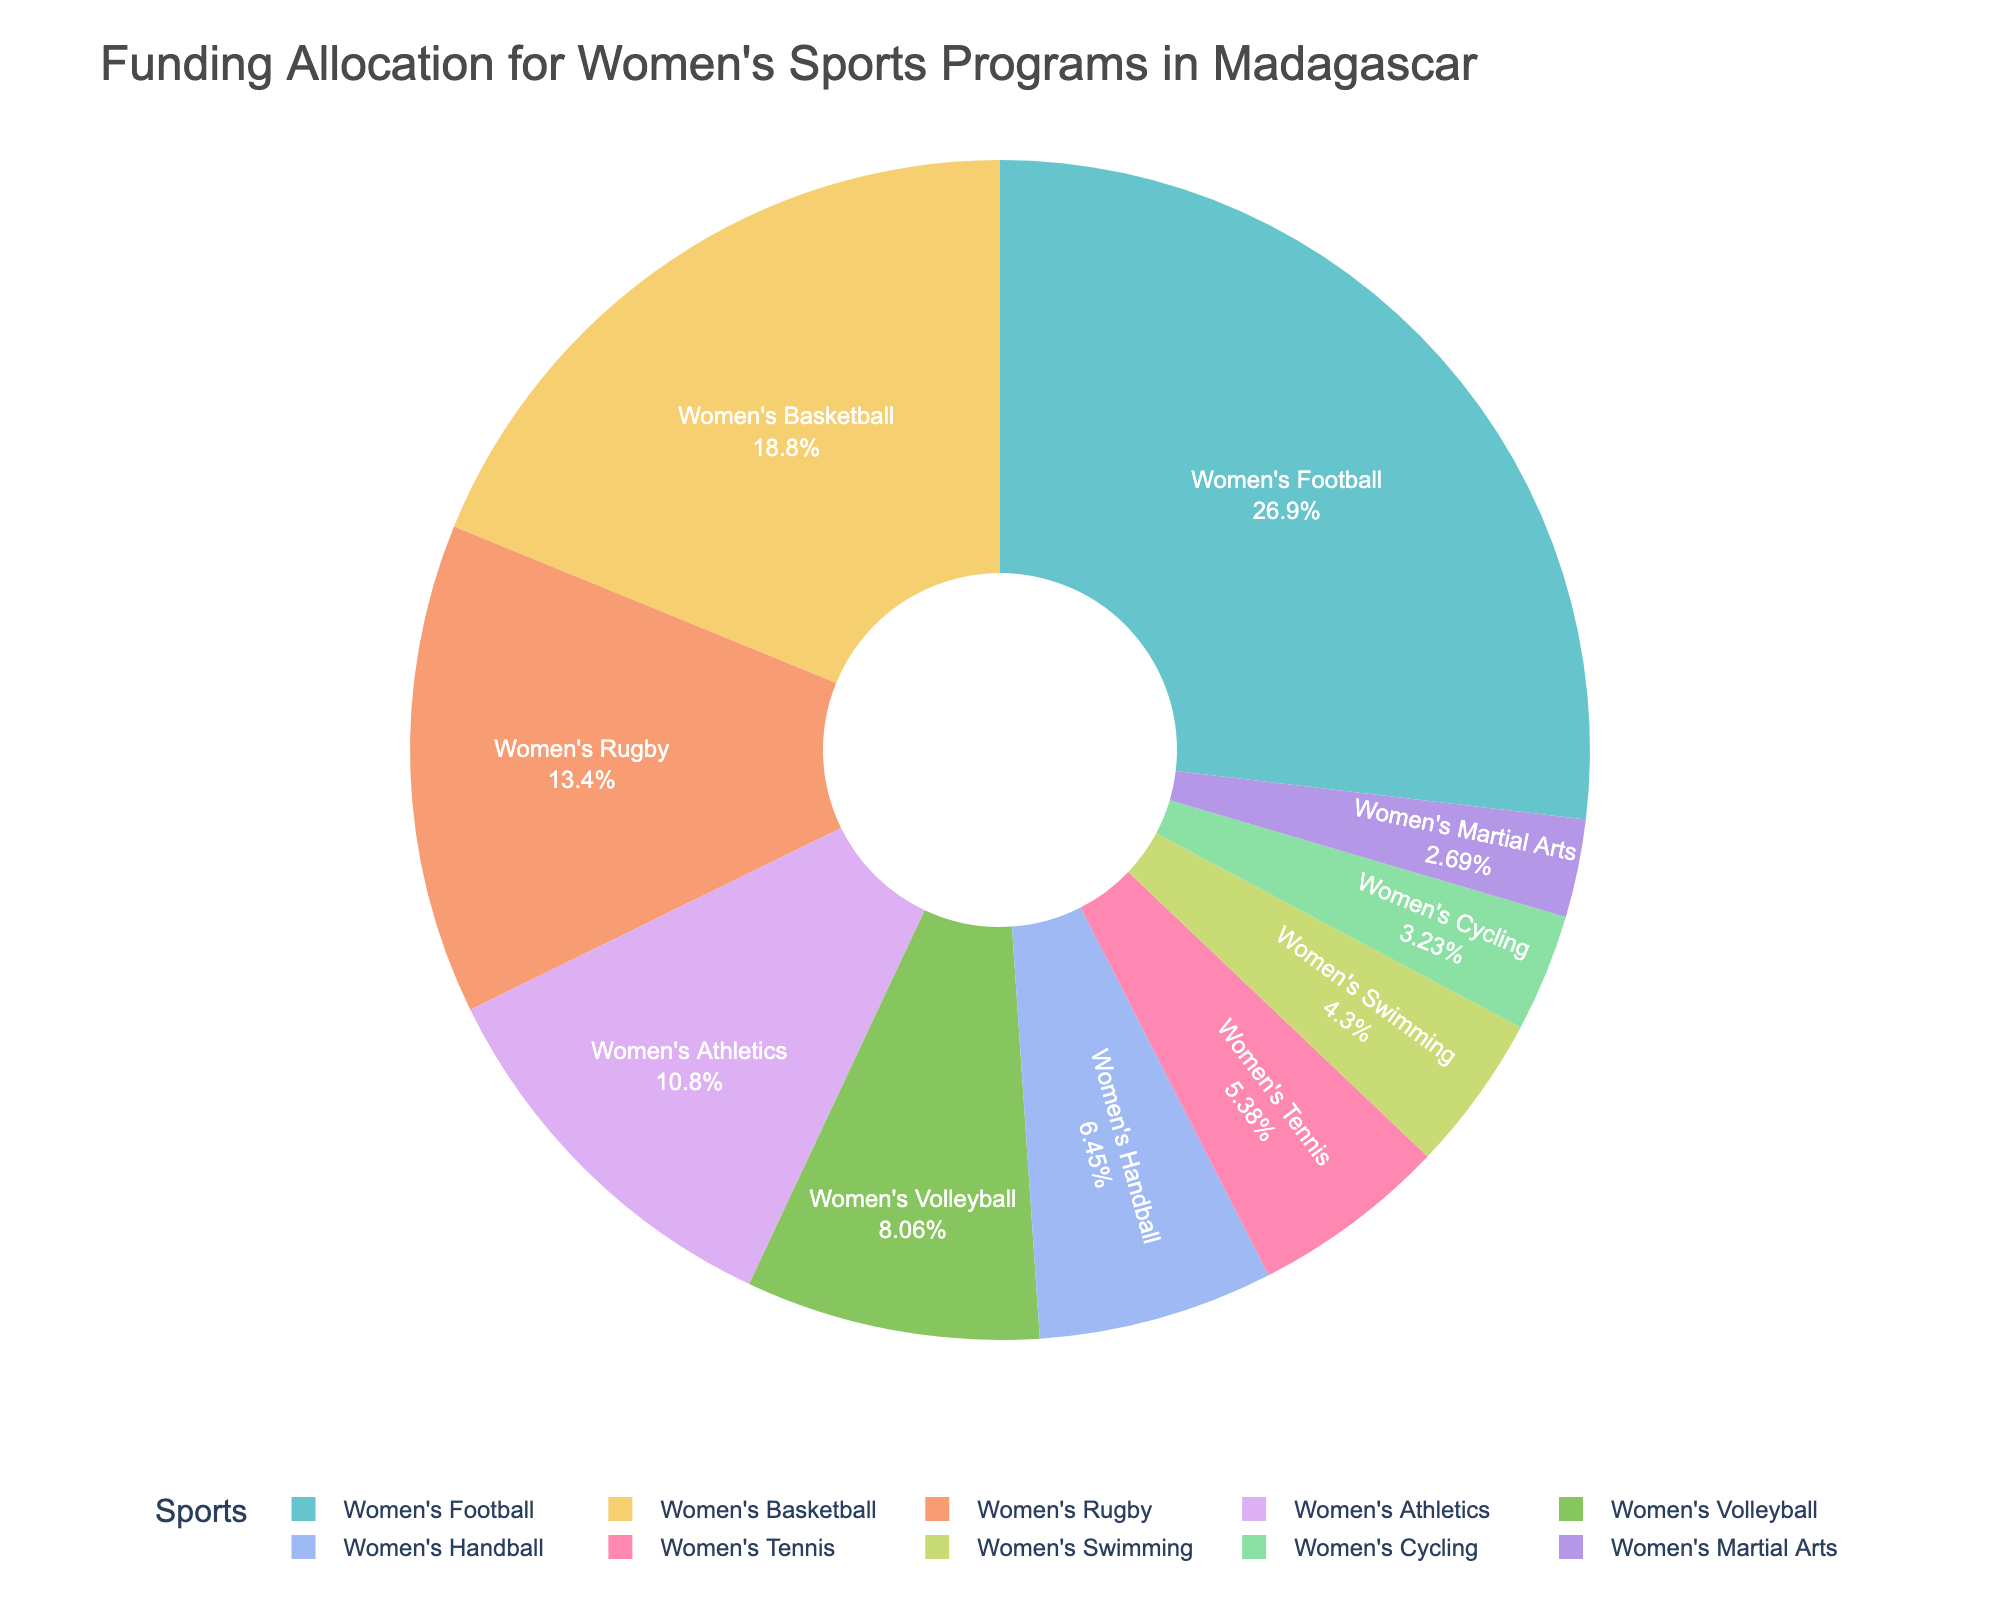What percentage of the total funding is allocated to women's football? To find the percentage of total funding allocated to women's football, divide the funding for women's football (125,000,000 Malagasy Ariary) by the total funding and multiply by 100. From the pie chart, the percentage is displayed directly.
Answer: 30.0% Which sport receives the least funding? Look for the smallest slice in the pie chart. The smallest slice represents the sport with the least funding, which, from the data, is women's martial arts.
Answer: Women's Martial Arts What is the combined funding percentage for women's basketball and women's volleyball? Add the percentages for women's basketball and women's volleyball from the pie chart. Women's basketball is 21.0% and women’s volleyball is 9.0%. Therefore, 21.0% + 9.0% = 30.0%.
Answer: 30.0% Is the funding for women's swimming greater than the funding for women's handball? Compare the sizes of the slices for women's swimming and women's handball in the pie chart. Women's handball has a larger slice (7.2%) than women's swimming (4.8%), indicating more funding.
Answer: No What is the difference in funding allocation between women's rugby and women's tennis? Subtract the funding for women's tennis (25,000,000 Malagasy Ariary) from the funding for women's rugby (62,500,000 Malagasy Ariary). 62,500,000 - 25,000,000 = 37,500,000 Malagasy Ariary.
Answer: 37,500,000 Malagasy Ariary Which sport receives twice the fraction of the total funding as women's cycling? Identify the funding percentage of women's cycling (3.6%) and look for a sport that has a slice representing approximately double that percentage, i.e., around 7.2%. Women's handball fits this criterion.
Answer: Women's Handball How much more funding does women's football receive compared to women's athletics? Subtract the funding for women's athletics (50,000,000 Malagasy Ariary) from the funding for women's football (125,000,000 Malagasy Ariary). 125,000,000 - 50,000,000 = 75,000,000 Malagasy Ariary.
Answer: 75,000,000 Malagasy Ariary Rank the sports by their funding allocations from highest to lowest. Based on the slices in the pie chart, the order of sports by funding allocation is women’s football, women’s basketball, women’s rugby, women’s athletics, women’s volleyball, women’s handball, women’s tennis, women’s swimming, women’s cycling, women’s martial arts.
Answer: Women's Football, Women's Basketball, Women's Rugby, Women's Athletics, Women's Volleyball, Women's Handball, Women's Tennis, Women's Swimming, Women's Cycling, Women's Martial Arts Which sports receive the same amount of funding? Check the slices of equal size on the pie chart. None of the sports show equal-sized slices, indicating they all receive different amounts of funding.
Answer: None What is the average percentage of funding allocated to women's tennis, women's swimming, and women's martial arts? Calculate the sum of the percentages for women's tennis (6.0%), women's swimming (4.8%), and women's martial arts (3.0%), and divide by the number of sports (3). Total percentage is 6.0% + 4.8% + 3.0% = 13.8%, so average is 13.8% / 3 = 4.6%.
Answer: 4.6% 